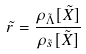<formula> <loc_0><loc_0><loc_500><loc_500>\tilde { r } = \frac { \rho _ { \tilde { \Lambda } } [ \tilde { X } ] } { \rho _ { \tilde { s } } [ \tilde { X } ] }</formula> 